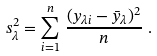Convert formula to latex. <formula><loc_0><loc_0><loc_500><loc_500>s ^ { 2 } _ { \lambda } = \sum ^ { n } _ { i = 1 } \left . \frac { ( y _ { \lambda i } - \bar { y } _ { \lambda } ) ^ { 2 } } { n } \right . .</formula> 